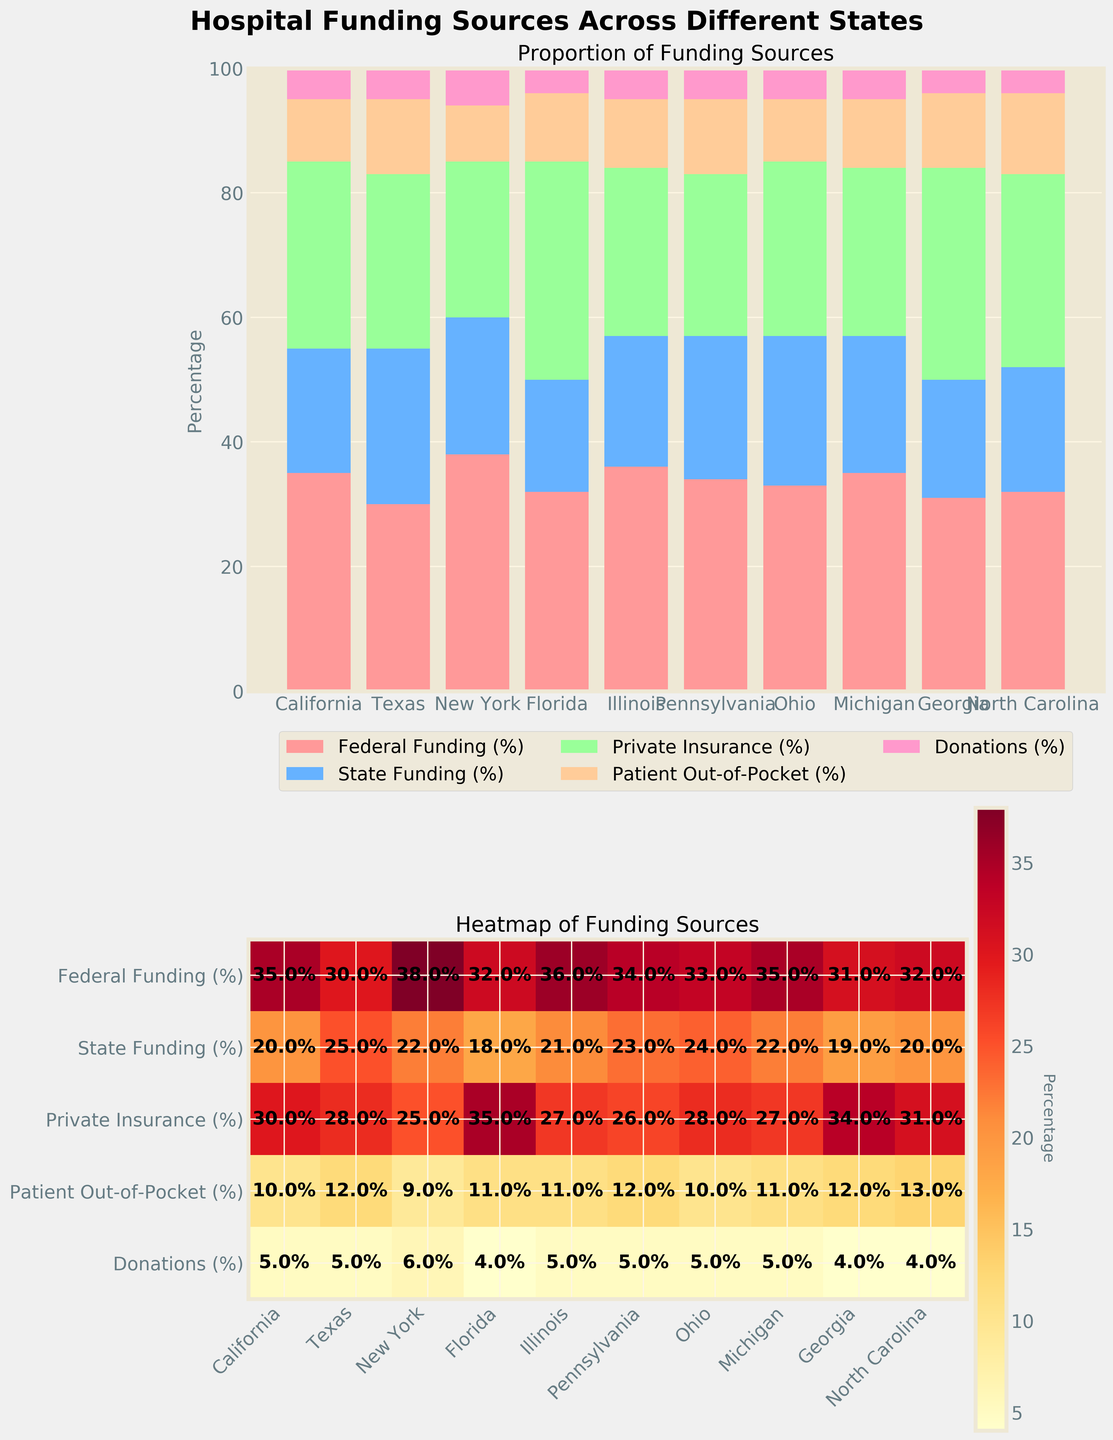What is the title of the figure? The title of the figure is written at the top in a larger and bolder font compared to other text. It encapsulates the main focus of the figure, providing an overall description.
Answer: Hospital Funding Sources Across Different States Which state has the highest proportion of Federal Funding? From the stacked bar chart, compare the height of the section representing Federal Funding across all states. The tallest section belongs to New York, indicating it has the highest proportion.
Answer: New York How much is the Patient Out-of-Pocket funding in Texas? Check the section of the bar corresponding to Patient Out-of-Pocket funding for Texas in the stacked bar chart or the value directly in the heatmap. It shows a percentage of 12.
Answer: 12% Compare the Private Insurance funding between Florida and Ohio. Which state has a higher proportion and by how much? Look at the height of the Private Insurance section in both Florida and Ohio's bars, or refer to the heatmap. Florida has 35%, and Ohio has 28%. Subtract Ohio's value from Florida's to get the difference.
Answer: Florida, 7% What is the median value of Federal Funding across the states? List the Federal Funding percentages: 30, 31, 32, 32, 33, 34, 35, 35, 36, 38. With ten values, the median is the average of the 5th and 6th values when sorted in ascending order. The 5th and 6th values are 33 and 34. So, (33+34)/2 = 33.5.
Answer: 33.5% In which state is the State Funding closest to 20%? Refer to the heatmap for the State Funding column; find the value closest to 20%, which appears to be Michigan and California both at 20%. Thus, you can mention either.
Answer: California or Michigan Which state has the least amount of Donations? Using the heatmap where Donations for each state are listed, find the smallest value. It is Florida with 4%.
Answer: Florida Sum the percentages of Private Insurance and State Funding for Illinois. For Illinois, add the values for Private Insurance (27%) and State Funding (21%), yielding 27 + 21 = 48%.
Answer: 48% Which funding source shows the highest variability across different states? Visually inspect the heatmap to determine the range of percentages across states for each funding source. Federal Funding ranges from 30% to 38%, while Private Insurance spans from 25% to 35%. These ranges indicate Federal Funding has a higher variability.
Answer: Federal Funding Is the proportion of Donations higher in Pennsylvania or Georgia? Refer to the Donations section of the heatmap. Pennsylvania has 5%, and Georgia shows 4%. Thus, Pennsylvania has higher Donations.
Answer: Pennsylvania 